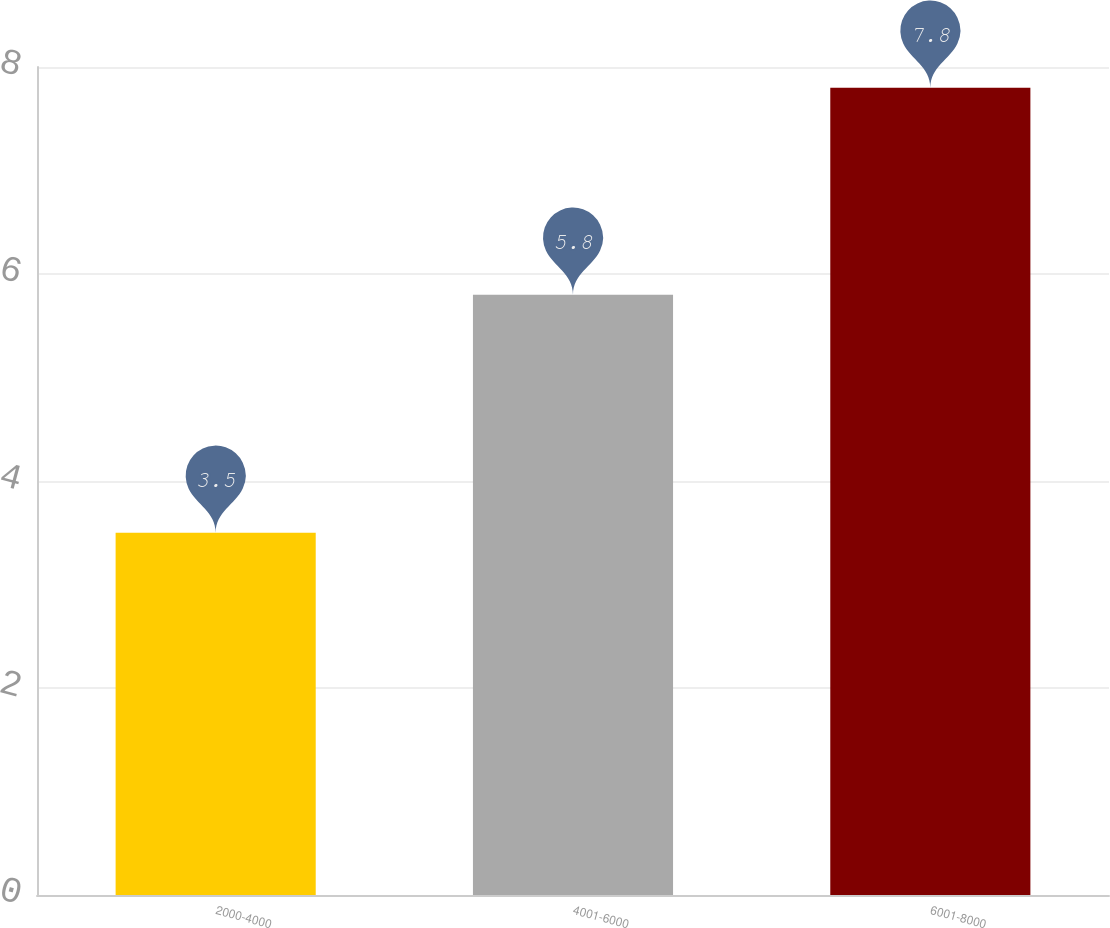Convert chart. <chart><loc_0><loc_0><loc_500><loc_500><bar_chart><fcel>2000-4000<fcel>4001-6000<fcel>6001-8000<nl><fcel>3.5<fcel>5.8<fcel>7.8<nl></chart> 